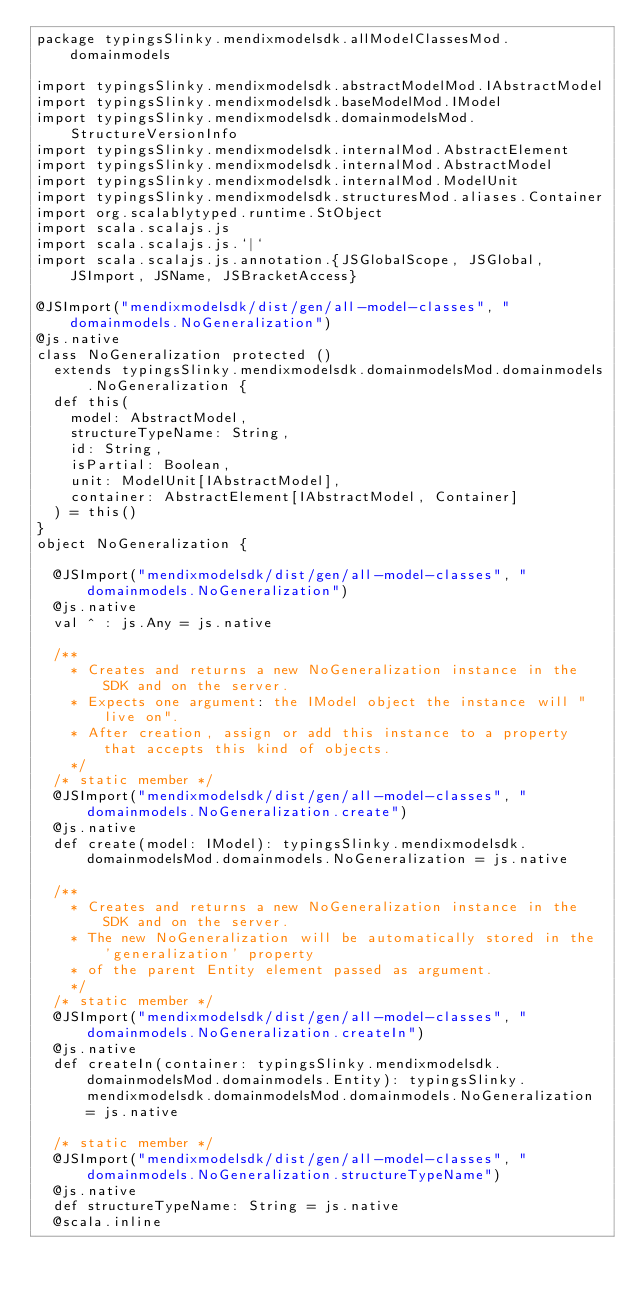Convert code to text. <code><loc_0><loc_0><loc_500><loc_500><_Scala_>package typingsSlinky.mendixmodelsdk.allModelClassesMod.domainmodels

import typingsSlinky.mendixmodelsdk.abstractModelMod.IAbstractModel
import typingsSlinky.mendixmodelsdk.baseModelMod.IModel
import typingsSlinky.mendixmodelsdk.domainmodelsMod.StructureVersionInfo
import typingsSlinky.mendixmodelsdk.internalMod.AbstractElement
import typingsSlinky.mendixmodelsdk.internalMod.AbstractModel
import typingsSlinky.mendixmodelsdk.internalMod.ModelUnit
import typingsSlinky.mendixmodelsdk.structuresMod.aliases.Container
import org.scalablytyped.runtime.StObject
import scala.scalajs.js
import scala.scalajs.js.`|`
import scala.scalajs.js.annotation.{JSGlobalScope, JSGlobal, JSImport, JSName, JSBracketAccess}

@JSImport("mendixmodelsdk/dist/gen/all-model-classes", "domainmodels.NoGeneralization")
@js.native
class NoGeneralization protected ()
  extends typingsSlinky.mendixmodelsdk.domainmodelsMod.domainmodels.NoGeneralization {
  def this(
    model: AbstractModel,
    structureTypeName: String,
    id: String,
    isPartial: Boolean,
    unit: ModelUnit[IAbstractModel],
    container: AbstractElement[IAbstractModel, Container]
  ) = this()
}
object NoGeneralization {
  
  @JSImport("mendixmodelsdk/dist/gen/all-model-classes", "domainmodels.NoGeneralization")
  @js.native
  val ^ : js.Any = js.native
  
  /**
    * Creates and returns a new NoGeneralization instance in the SDK and on the server.
    * Expects one argument: the IModel object the instance will "live on".
    * After creation, assign or add this instance to a property that accepts this kind of objects.
    */
  /* static member */
  @JSImport("mendixmodelsdk/dist/gen/all-model-classes", "domainmodels.NoGeneralization.create")
  @js.native
  def create(model: IModel): typingsSlinky.mendixmodelsdk.domainmodelsMod.domainmodels.NoGeneralization = js.native
  
  /**
    * Creates and returns a new NoGeneralization instance in the SDK and on the server.
    * The new NoGeneralization will be automatically stored in the 'generalization' property
    * of the parent Entity element passed as argument.
    */
  /* static member */
  @JSImport("mendixmodelsdk/dist/gen/all-model-classes", "domainmodels.NoGeneralization.createIn")
  @js.native
  def createIn(container: typingsSlinky.mendixmodelsdk.domainmodelsMod.domainmodels.Entity): typingsSlinky.mendixmodelsdk.domainmodelsMod.domainmodels.NoGeneralization = js.native
  
  /* static member */
  @JSImport("mendixmodelsdk/dist/gen/all-model-classes", "domainmodels.NoGeneralization.structureTypeName")
  @js.native
  def structureTypeName: String = js.native
  @scala.inline</code> 